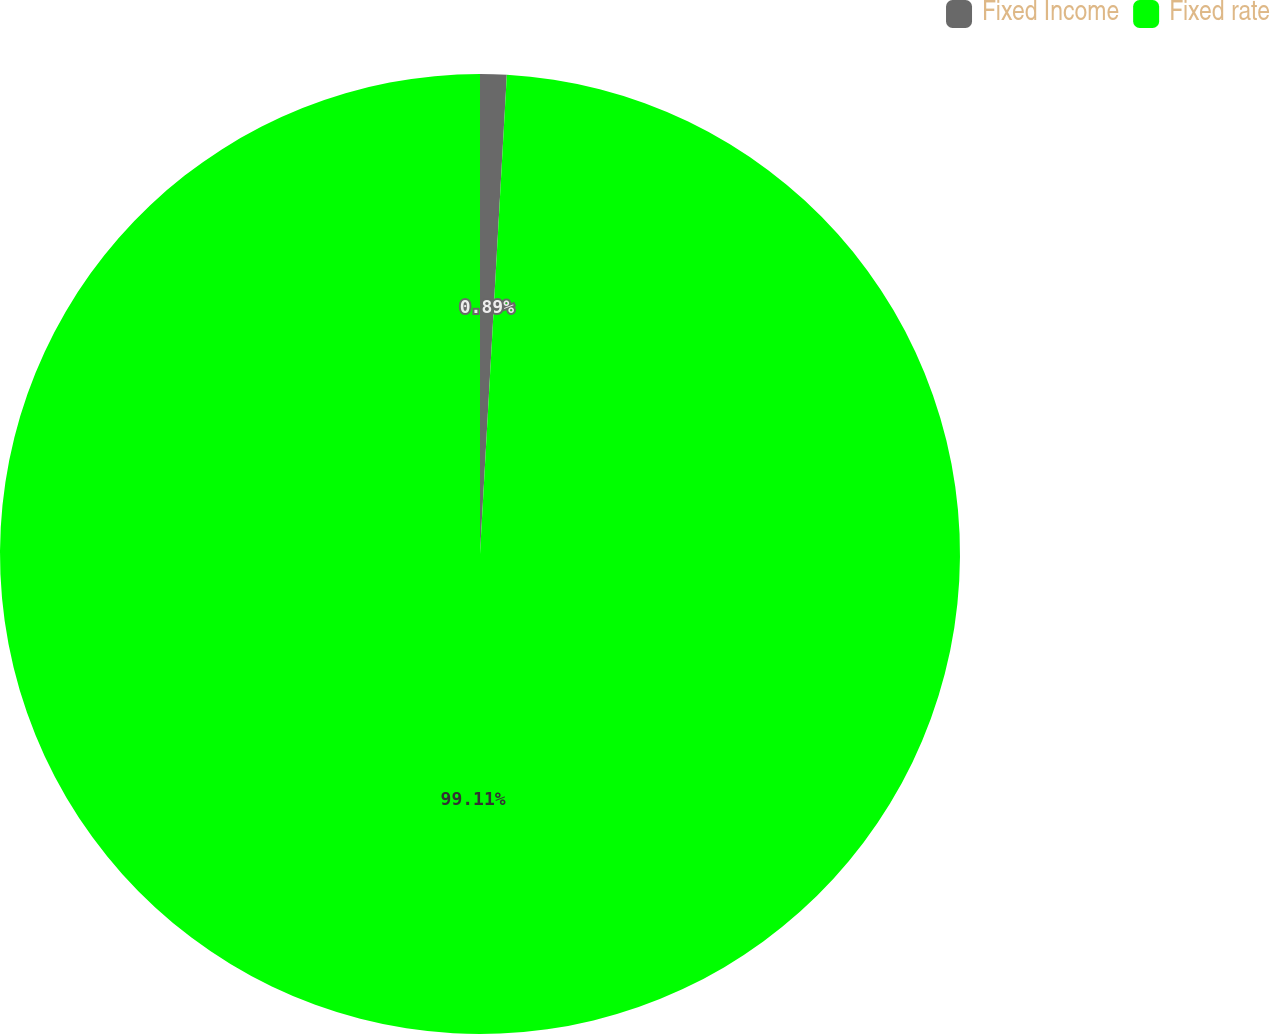Convert chart to OTSL. <chart><loc_0><loc_0><loc_500><loc_500><pie_chart><fcel>Fixed Income<fcel>Fixed rate<nl><fcel>0.89%<fcel>99.11%<nl></chart> 